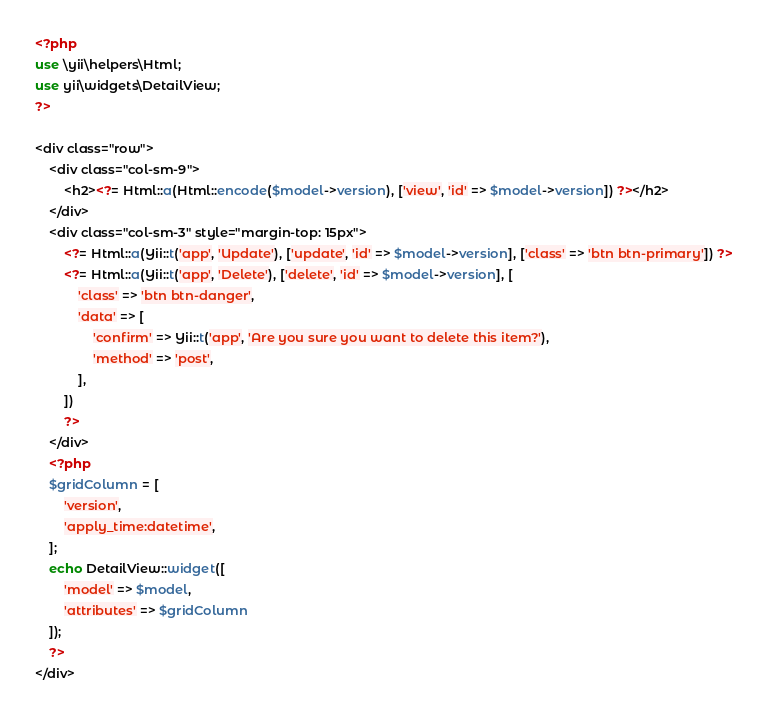<code> <loc_0><loc_0><loc_500><loc_500><_PHP_><?php 
use \yii\helpers\Html;
use yii\widgets\DetailView;
?>

<div class="row">
    <div class="col-sm-9">
        <h2><?= Html::a(Html::encode($model->version), ['view', 'id' => $model->version]) ?></h2>
    </div>
    <div class="col-sm-3" style="margin-top: 15px">
        <?= Html::a(Yii::t('app', 'Update'), ['update', 'id' => $model->version], ['class' => 'btn btn-primary']) ?>
        <?= Html::a(Yii::t('app', 'Delete'), ['delete', 'id' => $model->version], [
            'class' => 'btn btn-danger',
            'data' => [
                'confirm' => Yii::t('app', 'Are you sure you want to delete this item?'),
                'method' => 'post',
            ],
        ])
        ?>
    </div>
    <?php 
    $gridColumn = [
        'version',
        'apply_time:datetime',
    ];
    echo DetailView::widget([
        'model' => $model,
        'attributes' => $gridColumn
    ]);
    ?>
</div>


</code> 